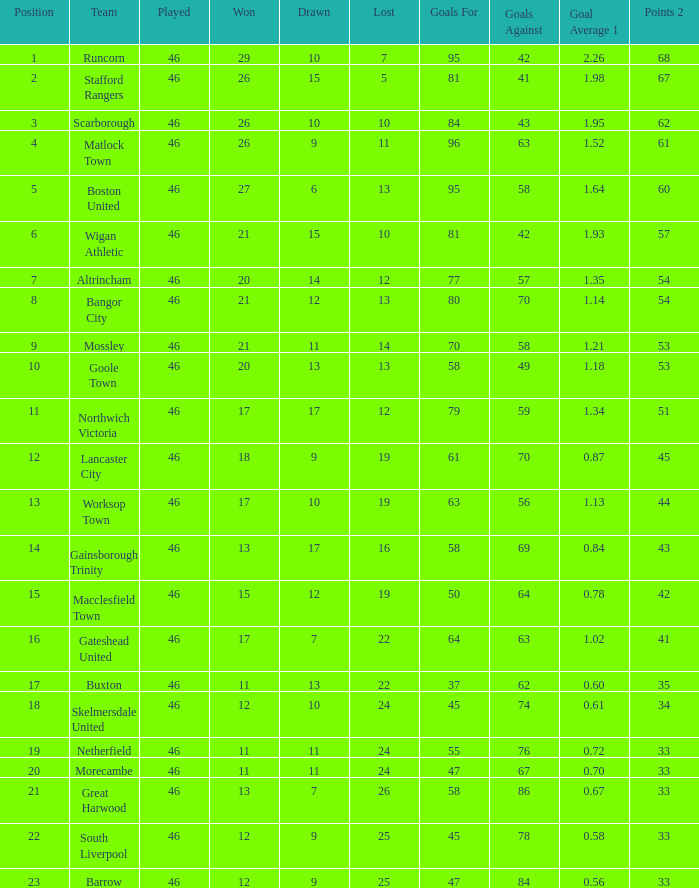Which team had goal ratios of Northwich Victoria. 